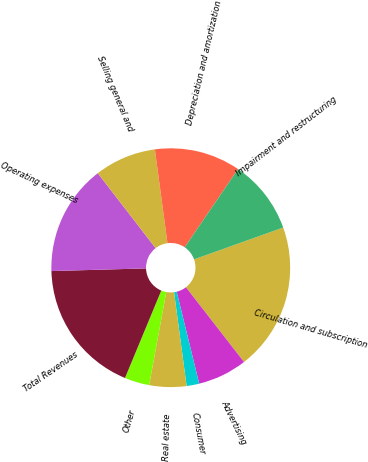Convert chart to OTSL. <chart><loc_0><loc_0><loc_500><loc_500><pie_chart><fcel>Circulation and subscription<fcel>Advertising<fcel>Consumer<fcel>Real estate<fcel>Other<fcel>Total Revenues<fcel>Operating expenses<fcel>Selling general and<fcel>Depreciation and amortization<fcel>Impairment and restructuring<nl><fcel>19.95%<fcel>6.68%<fcel>1.71%<fcel>5.02%<fcel>3.36%<fcel>18.29%<fcel>14.98%<fcel>8.34%<fcel>11.66%<fcel>10.0%<nl></chart> 